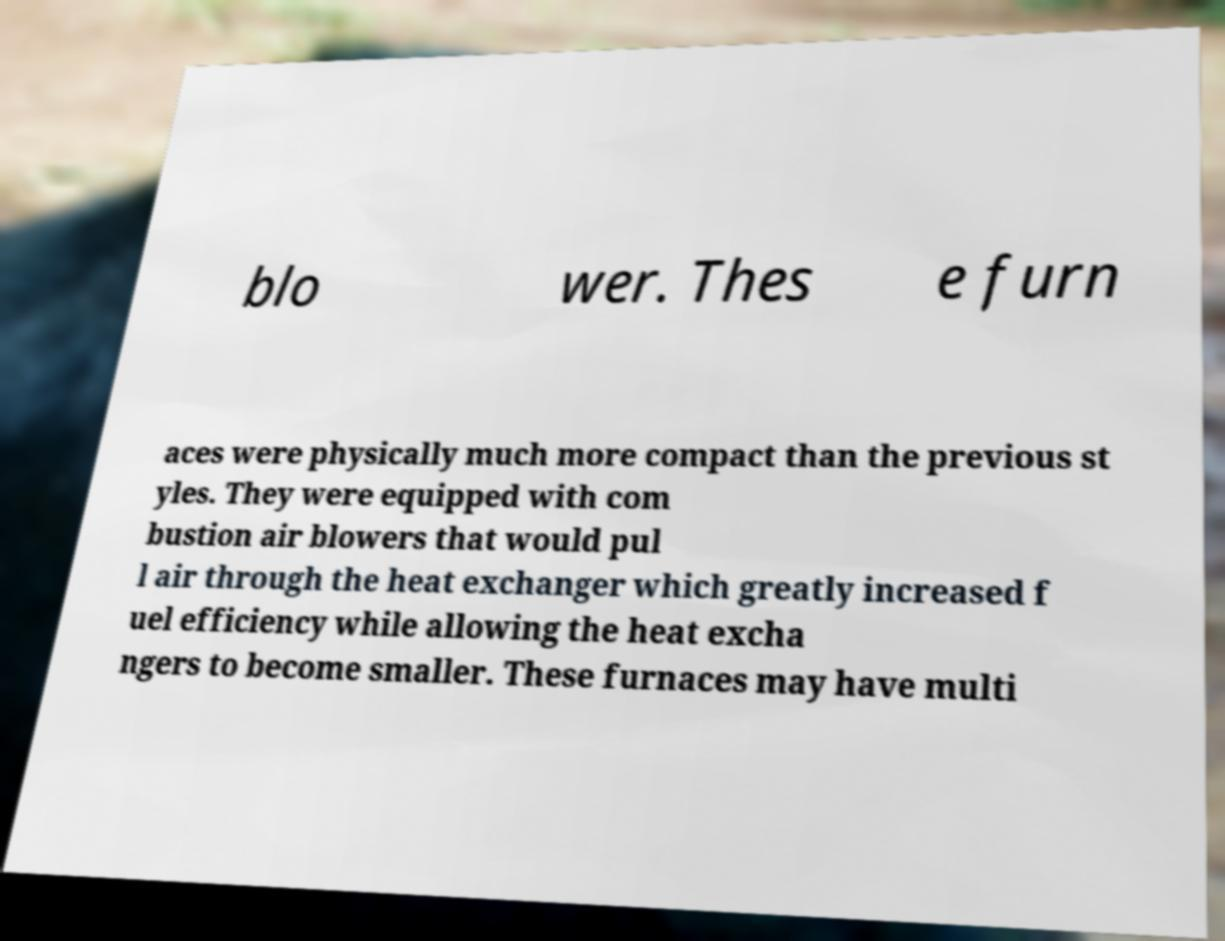Please read and relay the text visible in this image. What does it say? blo wer. Thes e furn aces were physically much more compact than the previous st yles. They were equipped with com bustion air blowers that would pul l air through the heat exchanger which greatly increased f uel efficiency while allowing the heat excha ngers to become smaller. These furnaces may have multi 